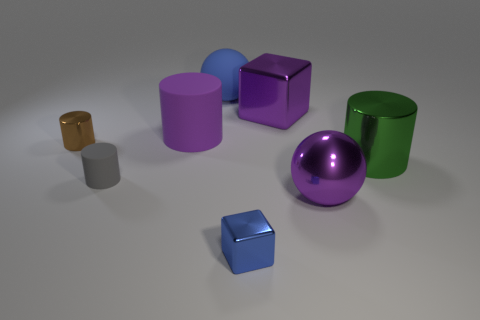Add 1 blue metal spheres. How many objects exist? 9 Subtract all blocks. How many objects are left? 6 Add 2 large blue matte balls. How many large blue matte balls are left? 3 Add 4 tiny gray spheres. How many tiny gray spheres exist? 4 Subtract 0 yellow cylinders. How many objects are left? 8 Subtract all purple spheres. Subtract all purple matte cylinders. How many objects are left? 6 